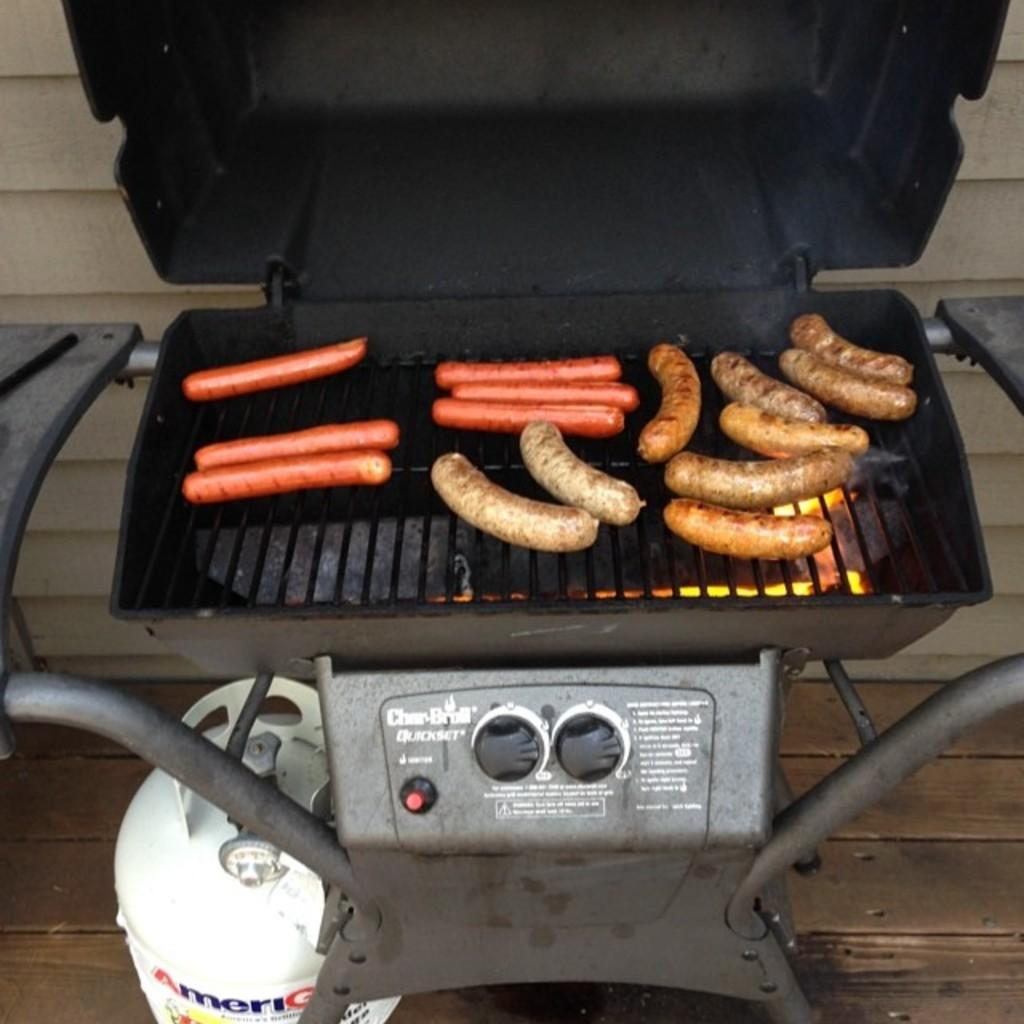What type of food is being cooked on the barbecue in the image? There are hot dogs on the barbecue in the image. What objects can be seen near the barbecue? There are rods and buttons visible in the image. What is the white object on the floor in the image? There is a white cylinder on the floor in the image. What is visible in the background of the image? There is a wall in the background of the image. What type of animal can be seen interacting with the hot dogs on the barbecue in the image? There are no animals present in the image; it only features hot dogs on the barbecue, rods and buttons, a white cylinder, and a wall in the background. 